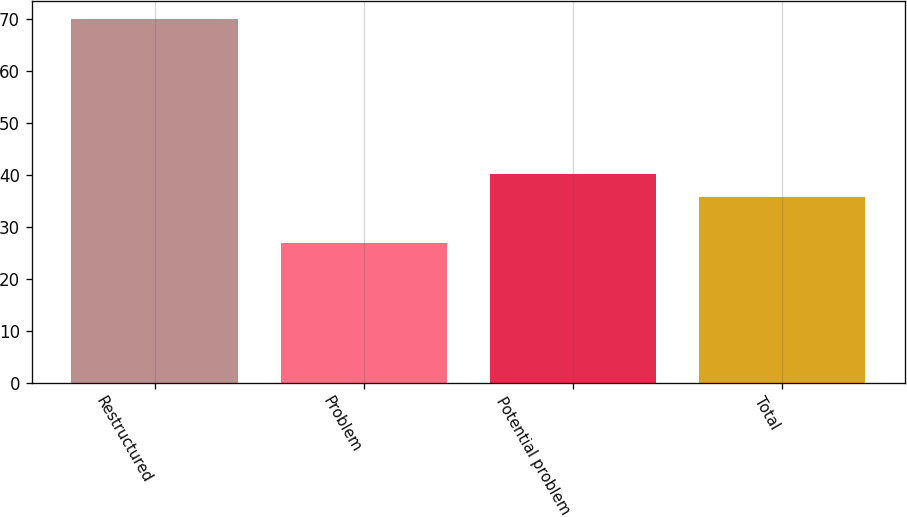Convert chart to OTSL. <chart><loc_0><loc_0><loc_500><loc_500><bar_chart><fcel>Restructured<fcel>Problem<fcel>Potential problem<fcel>Total<nl><fcel>70.1<fcel>26.9<fcel>40.12<fcel>35.8<nl></chart> 